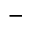<formula> <loc_0><loc_0><loc_500><loc_500>-</formula> 